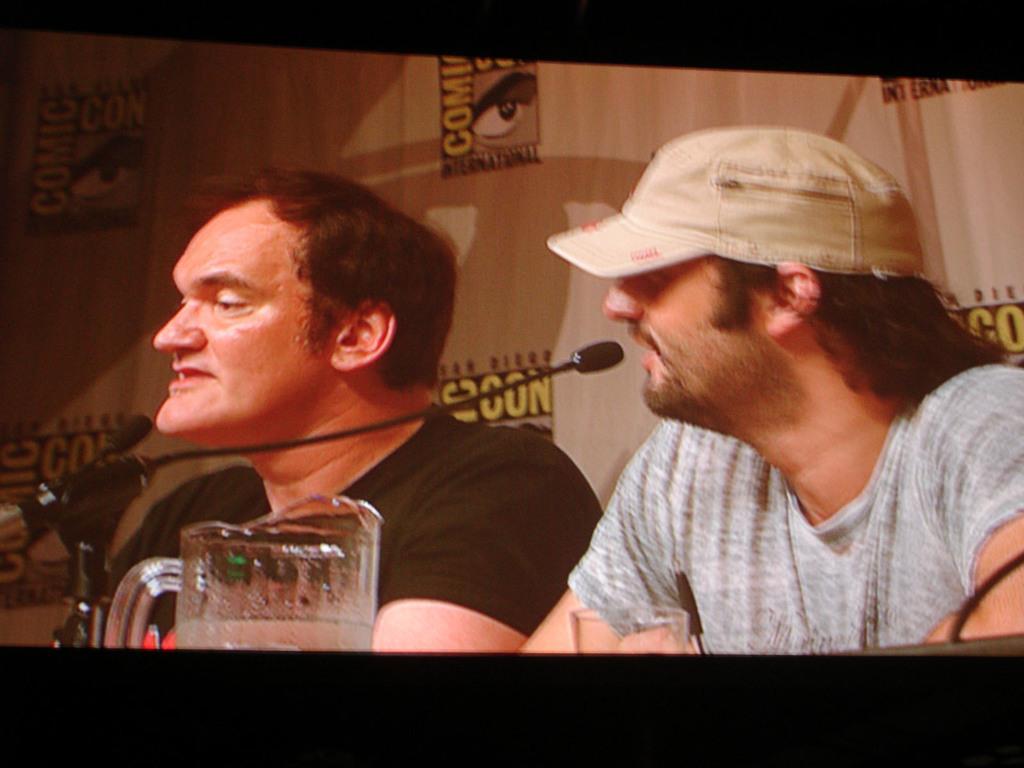In one or two sentences, can you explain what this image depicts? In this image I can see a huge screen and in the screen I can see two persons, a glass and a microphone in front of them. I can see the brown colored background. 